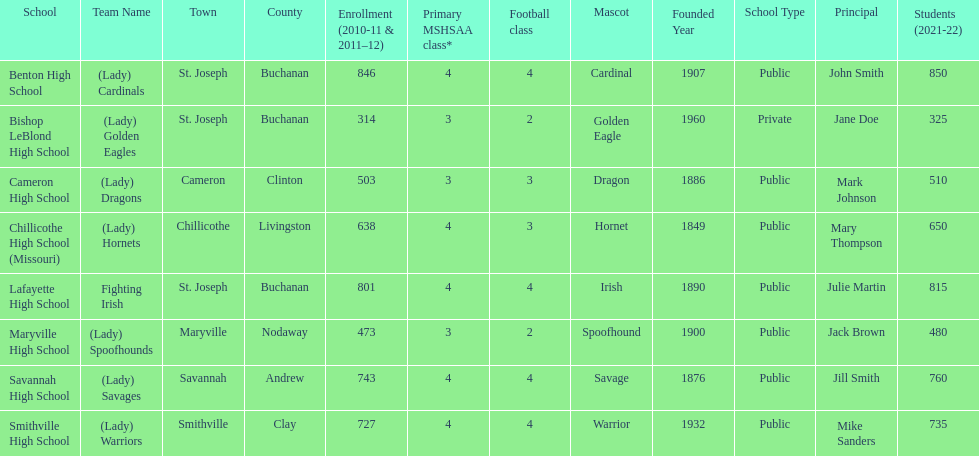How many teams are named after birds? 2. 